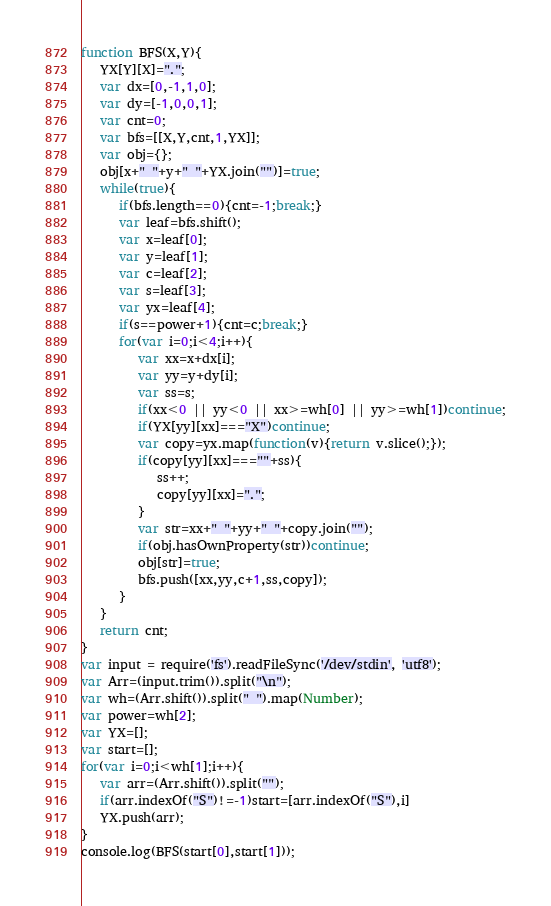<code> <loc_0><loc_0><loc_500><loc_500><_JavaScript_>function BFS(X,Y){
   YX[Y][X]=".";
   var dx=[0,-1,1,0];
   var dy=[-1,0,0,1];
   var cnt=0;
   var bfs=[[X,Y,cnt,1,YX]];
   var obj={};
   obj[x+" "+y+" "+YX.join("")]=true;
   while(true){
      if(bfs.length==0){cnt=-1;break;}
      var leaf=bfs.shift();
      var x=leaf[0];
      var y=leaf[1];
      var c=leaf[2];
      var s=leaf[3];
      var yx=leaf[4];
      if(s==power+1){cnt=c;break;}
      for(var i=0;i<4;i++){
         var xx=x+dx[i];
         var yy=y+dy[i];
         var ss=s;
         if(xx<0 || yy<0 || xx>=wh[0] || yy>=wh[1])continue;
         if(YX[yy][xx]==="X")continue;
         var copy=yx.map(function(v){return v.slice();});
         if(copy[yy][xx]===""+ss){
            ss++;
            copy[yy][xx]=".";
         }
         var str=xx+" "+yy+" "+copy.join("");
         if(obj.hasOwnProperty(str))continue;
         obj[str]=true;
         bfs.push([xx,yy,c+1,ss,copy]);
      }
   }
   return cnt;
}
var input = require('fs').readFileSync('/dev/stdin', 'utf8');
var Arr=(input.trim()).split("\n");
var wh=(Arr.shift()).split(" ").map(Number);
var power=wh[2];
var YX=[];
var start=[];
for(var i=0;i<wh[1];i++){
   var arr=(Arr.shift()).split("");
   if(arr.indexOf("S")!=-1)start=[arr.indexOf("S"),i]
   YX.push(arr);
}
console.log(BFS(start[0],start[1]));</code> 